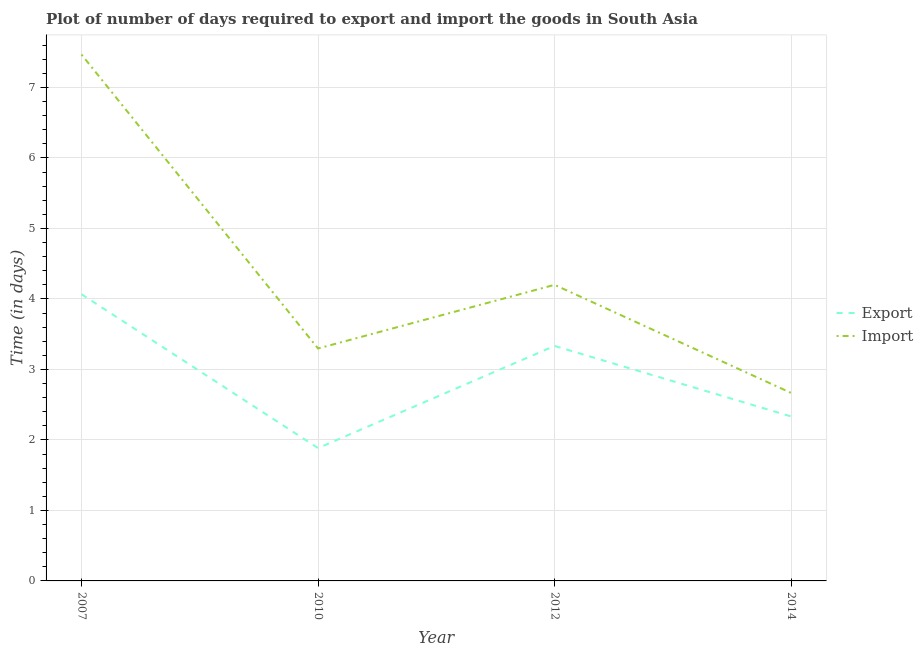How many different coloured lines are there?
Your answer should be very brief. 2. Does the line corresponding to time required to import intersect with the line corresponding to time required to export?
Ensure brevity in your answer.  No. Is the number of lines equal to the number of legend labels?
Offer a terse response. Yes. What is the time required to export in 2014?
Make the answer very short. 2.33. Across all years, what is the maximum time required to import?
Your response must be concise. 7.47. Across all years, what is the minimum time required to export?
Give a very brief answer. 1.88. In which year was the time required to export maximum?
Offer a terse response. 2007. What is the total time required to export in the graph?
Ensure brevity in your answer.  11.62. What is the difference between the time required to export in 2007 and that in 2014?
Provide a succinct answer. 1.73. What is the difference between the time required to export in 2012 and the time required to import in 2010?
Your answer should be compact. 0.04. What is the average time required to import per year?
Offer a terse response. 4.41. In the year 2007, what is the difference between the time required to import and time required to export?
Your response must be concise. 3.4. In how many years, is the time required to import greater than 1 days?
Offer a terse response. 4. What is the ratio of the time required to import in 2007 to that in 2012?
Make the answer very short. 1.78. Is the time required to import in 2010 less than that in 2012?
Give a very brief answer. Yes. Is the difference between the time required to export in 2007 and 2012 greater than the difference between the time required to import in 2007 and 2012?
Your answer should be very brief. No. What is the difference between the highest and the second highest time required to import?
Provide a short and direct response. 3.27. What is the difference between the highest and the lowest time required to import?
Your answer should be very brief. 4.8. Is the sum of the time required to export in 2010 and 2012 greater than the maximum time required to import across all years?
Your response must be concise. No. Does the time required to export monotonically increase over the years?
Offer a terse response. No. How many lines are there?
Your answer should be compact. 2. What is the difference between two consecutive major ticks on the Y-axis?
Offer a very short reply. 1. Does the graph contain any zero values?
Offer a very short reply. No. Does the graph contain grids?
Provide a short and direct response. Yes. Where does the legend appear in the graph?
Your answer should be very brief. Center right. How many legend labels are there?
Your answer should be very brief. 2. How are the legend labels stacked?
Provide a succinct answer. Vertical. What is the title of the graph?
Your answer should be compact. Plot of number of days required to export and import the goods in South Asia. Does "Electricity and heat production" appear as one of the legend labels in the graph?
Offer a terse response. No. What is the label or title of the X-axis?
Your answer should be very brief. Year. What is the label or title of the Y-axis?
Make the answer very short. Time (in days). What is the Time (in days) of Export in 2007?
Keep it short and to the point. 4.07. What is the Time (in days) in Import in 2007?
Make the answer very short. 7.47. What is the Time (in days) in Export in 2010?
Ensure brevity in your answer.  1.88. What is the Time (in days) of Import in 2010?
Keep it short and to the point. 3.3. What is the Time (in days) of Export in 2012?
Your response must be concise. 3.33. What is the Time (in days) of Export in 2014?
Your response must be concise. 2.33. What is the Time (in days) of Import in 2014?
Offer a very short reply. 2.67. Across all years, what is the maximum Time (in days) of Export?
Provide a short and direct response. 4.07. Across all years, what is the maximum Time (in days) of Import?
Provide a succinct answer. 7.47. Across all years, what is the minimum Time (in days) of Export?
Offer a very short reply. 1.88. Across all years, what is the minimum Time (in days) in Import?
Ensure brevity in your answer.  2.67. What is the total Time (in days) in Export in the graph?
Offer a terse response. 11.62. What is the total Time (in days) in Import in the graph?
Provide a succinct answer. 17.63. What is the difference between the Time (in days) of Export in 2007 and that in 2010?
Ensure brevity in your answer.  2.18. What is the difference between the Time (in days) of Import in 2007 and that in 2010?
Your response must be concise. 4.17. What is the difference between the Time (in days) in Export in 2007 and that in 2012?
Your response must be concise. 0.73. What is the difference between the Time (in days) in Import in 2007 and that in 2012?
Your response must be concise. 3.27. What is the difference between the Time (in days) of Export in 2007 and that in 2014?
Offer a terse response. 1.73. What is the difference between the Time (in days) of Import in 2007 and that in 2014?
Provide a succinct answer. 4.8. What is the difference between the Time (in days) of Export in 2010 and that in 2012?
Your response must be concise. -1.45. What is the difference between the Time (in days) of Import in 2010 and that in 2012?
Your answer should be very brief. -0.9. What is the difference between the Time (in days) of Export in 2010 and that in 2014?
Give a very brief answer. -0.45. What is the difference between the Time (in days) of Import in 2010 and that in 2014?
Your answer should be very brief. 0.63. What is the difference between the Time (in days) of Import in 2012 and that in 2014?
Provide a succinct answer. 1.53. What is the difference between the Time (in days) in Export in 2007 and the Time (in days) in Import in 2010?
Provide a short and direct response. 0.77. What is the difference between the Time (in days) of Export in 2007 and the Time (in days) of Import in 2012?
Offer a very short reply. -0.13. What is the difference between the Time (in days) of Export in 2010 and the Time (in days) of Import in 2012?
Offer a very short reply. -2.32. What is the difference between the Time (in days) in Export in 2010 and the Time (in days) in Import in 2014?
Keep it short and to the point. -0.78. What is the difference between the Time (in days) of Export in 2012 and the Time (in days) of Import in 2014?
Your answer should be very brief. 0.67. What is the average Time (in days) in Export per year?
Offer a very short reply. 2.9. What is the average Time (in days) of Import per year?
Give a very brief answer. 4.41. In the year 2007, what is the difference between the Time (in days) in Export and Time (in days) in Import?
Give a very brief answer. -3.4. In the year 2010, what is the difference between the Time (in days) of Export and Time (in days) of Import?
Provide a short and direct response. -1.41. In the year 2012, what is the difference between the Time (in days) in Export and Time (in days) in Import?
Your response must be concise. -0.87. What is the ratio of the Time (in days) in Export in 2007 to that in 2010?
Your response must be concise. 2.16. What is the ratio of the Time (in days) in Import in 2007 to that in 2010?
Make the answer very short. 2.26. What is the ratio of the Time (in days) of Export in 2007 to that in 2012?
Provide a short and direct response. 1.22. What is the ratio of the Time (in days) in Import in 2007 to that in 2012?
Provide a succinct answer. 1.78. What is the ratio of the Time (in days) in Export in 2007 to that in 2014?
Provide a succinct answer. 1.74. What is the ratio of the Time (in days) in Import in 2007 to that in 2014?
Provide a short and direct response. 2.8. What is the ratio of the Time (in days) of Export in 2010 to that in 2012?
Provide a short and direct response. 0.57. What is the ratio of the Time (in days) of Import in 2010 to that in 2012?
Your answer should be compact. 0.79. What is the ratio of the Time (in days) in Export in 2010 to that in 2014?
Offer a terse response. 0.81. What is the ratio of the Time (in days) of Import in 2010 to that in 2014?
Your answer should be very brief. 1.24. What is the ratio of the Time (in days) of Export in 2012 to that in 2014?
Give a very brief answer. 1.43. What is the ratio of the Time (in days) in Import in 2012 to that in 2014?
Provide a short and direct response. 1.57. What is the difference between the highest and the second highest Time (in days) of Export?
Offer a terse response. 0.73. What is the difference between the highest and the second highest Time (in days) of Import?
Keep it short and to the point. 3.27. What is the difference between the highest and the lowest Time (in days) of Export?
Provide a succinct answer. 2.18. What is the difference between the highest and the lowest Time (in days) in Import?
Offer a terse response. 4.8. 